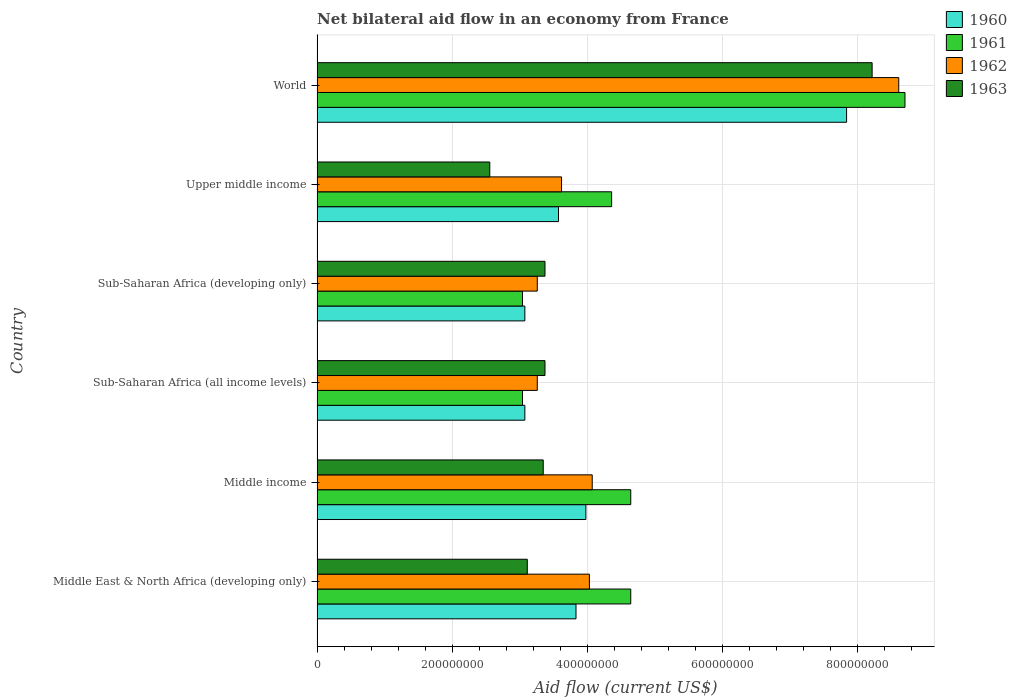How many different coloured bars are there?
Give a very brief answer. 4. How many groups of bars are there?
Keep it short and to the point. 6. How many bars are there on the 5th tick from the bottom?
Ensure brevity in your answer.  4. What is the label of the 3rd group of bars from the top?
Offer a terse response. Sub-Saharan Africa (developing only). In how many cases, is the number of bars for a given country not equal to the number of legend labels?
Your answer should be very brief. 0. What is the net bilateral aid flow in 1961 in World?
Provide a short and direct response. 8.70e+08. Across all countries, what is the maximum net bilateral aid flow in 1961?
Provide a succinct answer. 8.70e+08. Across all countries, what is the minimum net bilateral aid flow in 1962?
Give a very brief answer. 3.26e+08. In which country was the net bilateral aid flow in 1961 maximum?
Keep it short and to the point. World. In which country was the net bilateral aid flow in 1961 minimum?
Offer a very short reply. Sub-Saharan Africa (all income levels). What is the total net bilateral aid flow in 1961 in the graph?
Your answer should be very brief. 2.84e+09. What is the difference between the net bilateral aid flow in 1960 in Sub-Saharan Africa (all income levels) and that in Upper middle income?
Provide a short and direct response. -4.98e+07. What is the difference between the net bilateral aid flow in 1960 in Sub-Saharan Africa (developing only) and the net bilateral aid flow in 1961 in Upper middle income?
Your answer should be very brief. -1.28e+08. What is the average net bilateral aid flow in 1960 per country?
Offer a very short reply. 4.23e+08. What is the difference between the net bilateral aid flow in 1961 and net bilateral aid flow in 1963 in Sub-Saharan Africa (developing only)?
Give a very brief answer. -3.33e+07. In how many countries, is the net bilateral aid flow in 1961 greater than 200000000 US$?
Your response must be concise. 6. What is the ratio of the net bilateral aid flow in 1960 in Middle income to that in Sub-Saharan Africa (developing only)?
Offer a terse response. 1.29. What is the difference between the highest and the second highest net bilateral aid flow in 1961?
Make the answer very short. 4.06e+08. What is the difference between the highest and the lowest net bilateral aid flow in 1962?
Your answer should be very brief. 5.35e+08. In how many countries, is the net bilateral aid flow in 1962 greater than the average net bilateral aid flow in 1962 taken over all countries?
Keep it short and to the point. 1. Is the sum of the net bilateral aid flow in 1961 in Sub-Saharan Africa (all income levels) and World greater than the maximum net bilateral aid flow in 1963 across all countries?
Offer a terse response. Yes. Is it the case that in every country, the sum of the net bilateral aid flow in 1961 and net bilateral aid flow in 1960 is greater than the sum of net bilateral aid flow in 1963 and net bilateral aid flow in 1962?
Give a very brief answer. No. What does the 4th bar from the bottom in Middle East & North Africa (developing only) represents?
Keep it short and to the point. 1963. How many bars are there?
Your answer should be very brief. 24. Are all the bars in the graph horizontal?
Offer a terse response. Yes. How many countries are there in the graph?
Keep it short and to the point. 6. How many legend labels are there?
Ensure brevity in your answer.  4. What is the title of the graph?
Provide a succinct answer. Net bilateral aid flow in an economy from France. What is the label or title of the X-axis?
Your response must be concise. Aid flow (current US$). What is the label or title of the Y-axis?
Give a very brief answer. Country. What is the Aid flow (current US$) in 1960 in Middle East & North Africa (developing only)?
Offer a very short reply. 3.83e+08. What is the Aid flow (current US$) of 1961 in Middle East & North Africa (developing only)?
Ensure brevity in your answer.  4.64e+08. What is the Aid flow (current US$) in 1962 in Middle East & North Africa (developing only)?
Offer a very short reply. 4.03e+08. What is the Aid flow (current US$) of 1963 in Middle East & North Africa (developing only)?
Your response must be concise. 3.11e+08. What is the Aid flow (current US$) in 1960 in Middle income?
Provide a succinct answer. 3.98e+08. What is the Aid flow (current US$) in 1961 in Middle income?
Provide a succinct answer. 4.64e+08. What is the Aid flow (current US$) in 1962 in Middle income?
Your response must be concise. 4.07e+08. What is the Aid flow (current US$) of 1963 in Middle income?
Offer a very short reply. 3.35e+08. What is the Aid flow (current US$) of 1960 in Sub-Saharan Africa (all income levels)?
Give a very brief answer. 3.08e+08. What is the Aid flow (current US$) of 1961 in Sub-Saharan Africa (all income levels)?
Your answer should be compact. 3.04e+08. What is the Aid flow (current US$) of 1962 in Sub-Saharan Africa (all income levels)?
Keep it short and to the point. 3.26e+08. What is the Aid flow (current US$) of 1963 in Sub-Saharan Africa (all income levels)?
Ensure brevity in your answer.  3.37e+08. What is the Aid flow (current US$) of 1960 in Sub-Saharan Africa (developing only)?
Ensure brevity in your answer.  3.08e+08. What is the Aid flow (current US$) in 1961 in Sub-Saharan Africa (developing only)?
Your response must be concise. 3.04e+08. What is the Aid flow (current US$) in 1962 in Sub-Saharan Africa (developing only)?
Your response must be concise. 3.26e+08. What is the Aid flow (current US$) in 1963 in Sub-Saharan Africa (developing only)?
Your response must be concise. 3.37e+08. What is the Aid flow (current US$) of 1960 in Upper middle income?
Your answer should be compact. 3.57e+08. What is the Aid flow (current US$) in 1961 in Upper middle income?
Your answer should be compact. 4.36e+08. What is the Aid flow (current US$) in 1962 in Upper middle income?
Make the answer very short. 3.62e+08. What is the Aid flow (current US$) in 1963 in Upper middle income?
Provide a succinct answer. 2.56e+08. What is the Aid flow (current US$) of 1960 in World?
Your answer should be very brief. 7.84e+08. What is the Aid flow (current US$) in 1961 in World?
Your answer should be compact. 8.70e+08. What is the Aid flow (current US$) of 1962 in World?
Your response must be concise. 8.61e+08. What is the Aid flow (current US$) in 1963 in World?
Make the answer very short. 8.21e+08. Across all countries, what is the maximum Aid flow (current US$) in 1960?
Provide a short and direct response. 7.84e+08. Across all countries, what is the maximum Aid flow (current US$) in 1961?
Offer a very short reply. 8.70e+08. Across all countries, what is the maximum Aid flow (current US$) in 1962?
Your response must be concise. 8.61e+08. Across all countries, what is the maximum Aid flow (current US$) of 1963?
Give a very brief answer. 8.21e+08. Across all countries, what is the minimum Aid flow (current US$) in 1960?
Your response must be concise. 3.08e+08. Across all countries, what is the minimum Aid flow (current US$) in 1961?
Offer a terse response. 3.04e+08. Across all countries, what is the minimum Aid flow (current US$) of 1962?
Provide a succinct answer. 3.26e+08. Across all countries, what is the minimum Aid flow (current US$) in 1963?
Make the answer very short. 2.56e+08. What is the total Aid flow (current US$) in 1960 in the graph?
Provide a short and direct response. 2.54e+09. What is the total Aid flow (current US$) in 1961 in the graph?
Provide a short and direct response. 2.84e+09. What is the total Aid flow (current US$) of 1962 in the graph?
Make the answer very short. 2.68e+09. What is the total Aid flow (current US$) of 1963 in the graph?
Offer a terse response. 2.40e+09. What is the difference between the Aid flow (current US$) of 1960 in Middle East & North Africa (developing only) and that in Middle income?
Your response must be concise. -1.46e+07. What is the difference between the Aid flow (current US$) of 1961 in Middle East & North Africa (developing only) and that in Middle income?
Ensure brevity in your answer.  0. What is the difference between the Aid flow (current US$) of 1962 in Middle East & North Africa (developing only) and that in Middle income?
Make the answer very short. -4.20e+06. What is the difference between the Aid flow (current US$) of 1963 in Middle East & North Africa (developing only) and that in Middle income?
Make the answer very short. -2.36e+07. What is the difference between the Aid flow (current US$) in 1960 in Middle East & North Africa (developing only) and that in Sub-Saharan Africa (all income levels)?
Make the answer very short. 7.57e+07. What is the difference between the Aid flow (current US$) of 1961 in Middle East & North Africa (developing only) and that in Sub-Saharan Africa (all income levels)?
Give a very brief answer. 1.60e+08. What is the difference between the Aid flow (current US$) of 1962 in Middle East & North Africa (developing only) and that in Sub-Saharan Africa (all income levels)?
Give a very brief answer. 7.71e+07. What is the difference between the Aid flow (current US$) in 1963 in Middle East & North Africa (developing only) and that in Sub-Saharan Africa (all income levels)?
Give a very brief answer. -2.62e+07. What is the difference between the Aid flow (current US$) of 1960 in Middle East & North Africa (developing only) and that in Sub-Saharan Africa (developing only)?
Make the answer very short. 7.57e+07. What is the difference between the Aid flow (current US$) in 1961 in Middle East & North Africa (developing only) and that in Sub-Saharan Africa (developing only)?
Make the answer very short. 1.60e+08. What is the difference between the Aid flow (current US$) of 1962 in Middle East & North Africa (developing only) and that in Sub-Saharan Africa (developing only)?
Offer a terse response. 7.71e+07. What is the difference between the Aid flow (current US$) in 1963 in Middle East & North Africa (developing only) and that in Sub-Saharan Africa (developing only)?
Give a very brief answer. -2.62e+07. What is the difference between the Aid flow (current US$) in 1960 in Middle East & North Africa (developing only) and that in Upper middle income?
Provide a short and direct response. 2.59e+07. What is the difference between the Aid flow (current US$) in 1961 in Middle East & North Africa (developing only) and that in Upper middle income?
Your answer should be very brief. 2.83e+07. What is the difference between the Aid flow (current US$) of 1962 in Middle East & North Africa (developing only) and that in Upper middle income?
Keep it short and to the point. 4.12e+07. What is the difference between the Aid flow (current US$) of 1963 in Middle East & North Africa (developing only) and that in Upper middle income?
Offer a terse response. 5.55e+07. What is the difference between the Aid flow (current US$) in 1960 in Middle East & North Africa (developing only) and that in World?
Offer a very short reply. -4.00e+08. What is the difference between the Aid flow (current US$) in 1961 in Middle East & North Africa (developing only) and that in World?
Offer a very short reply. -4.06e+08. What is the difference between the Aid flow (current US$) in 1962 in Middle East & North Africa (developing only) and that in World?
Provide a short and direct response. -4.58e+08. What is the difference between the Aid flow (current US$) in 1963 in Middle East & North Africa (developing only) and that in World?
Ensure brevity in your answer.  -5.10e+08. What is the difference between the Aid flow (current US$) of 1960 in Middle income and that in Sub-Saharan Africa (all income levels)?
Your answer should be compact. 9.03e+07. What is the difference between the Aid flow (current US$) in 1961 in Middle income and that in Sub-Saharan Africa (all income levels)?
Ensure brevity in your answer.  1.60e+08. What is the difference between the Aid flow (current US$) of 1962 in Middle income and that in Sub-Saharan Africa (all income levels)?
Keep it short and to the point. 8.13e+07. What is the difference between the Aid flow (current US$) of 1963 in Middle income and that in Sub-Saharan Africa (all income levels)?
Provide a succinct answer. -2.60e+06. What is the difference between the Aid flow (current US$) in 1960 in Middle income and that in Sub-Saharan Africa (developing only)?
Offer a terse response. 9.03e+07. What is the difference between the Aid flow (current US$) in 1961 in Middle income and that in Sub-Saharan Africa (developing only)?
Make the answer very short. 1.60e+08. What is the difference between the Aid flow (current US$) in 1962 in Middle income and that in Sub-Saharan Africa (developing only)?
Your answer should be very brief. 8.13e+07. What is the difference between the Aid flow (current US$) in 1963 in Middle income and that in Sub-Saharan Africa (developing only)?
Ensure brevity in your answer.  -2.60e+06. What is the difference between the Aid flow (current US$) of 1960 in Middle income and that in Upper middle income?
Give a very brief answer. 4.05e+07. What is the difference between the Aid flow (current US$) of 1961 in Middle income and that in Upper middle income?
Your response must be concise. 2.83e+07. What is the difference between the Aid flow (current US$) of 1962 in Middle income and that in Upper middle income?
Offer a terse response. 4.54e+07. What is the difference between the Aid flow (current US$) in 1963 in Middle income and that in Upper middle income?
Your response must be concise. 7.91e+07. What is the difference between the Aid flow (current US$) in 1960 in Middle income and that in World?
Make the answer very short. -3.86e+08. What is the difference between the Aid flow (current US$) in 1961 in Middle income and that in World?
Ensure brevity in your answer.  -4.06e+08. What is the difference between the Aid flow (current US$) in 1962 in Middle income and that in World?
Offer a terse response. -4.54e+08. What is the difference between the Aid flow (current US$) in 1963 in Middle income and that in World?
Provide a short and direct response. -4.87e+08. What is the difference between the Aid flow (current US$) of 1960 in Sub-Saharan Africa (all income levels) and that in Sub-Saharan Africa (developing only)?
Provide a succinct answer. 0. What is the difference between the Aid flow (current US$) of 1961 in Sub-Saharan Africa (all income levels) and that in Sub-Saharan Africa (developing only)?
Provide a short and direct response. 0. What is the difference between the Aid flow (current US$) in 1963 in Sub-Saharan Africa (all income levels) and that in Sub-Saharan Africa (developing only)?
Ensure brevity in your answer.  0. What is the difference between the Aid flow (current US$) in 1960 in Sub-Saharan Africa (all income levels) and that in Upper middle income?
Give a very brief answer. -4.98e+07. What is the difference between the Aid flow (current US$) of 1961 in Sub-Saharan Africa (all income levels) and that in Upper middle income?
Your answer should be compact. -1.32e+08. What is the difference between the Aid flow (current US$) of 1962 in Sub-Saharan Africa (all income levels) and that in Upper middle income?
Your answer should be compact. -3.59e+07. What is the difference between the Aid flow (current US$) in 1963 in Sub-Saharan Africa (all income levels) and that in Upper middle income?
Offer a very short reply. 8.17e+07. What is the difference between the Aid flow (current US$) in 1960 in Sub-Saharan Africa (all income levels) and that in World?
Ensure brevity in your answer.  -4.76e+08. What is the difference between the Aid flow (current US$) in 1961 in Sub-Saharan Africa (all income levels) and that in World?
Make the answer very short. -5.66e+08. What is the difference between the Aid flow (current US$) in 1962 in Sub-Saharan Africa (all income levels) and that in World?
Provide a succinct answer. -5.35e+08. What is the difference between the Aid flow (current US$) in 1963 in Sub-Saharan Africa (all income levels) and that in World?
Give a very brief answer. -4.84e+08. What is the difference between the Aid flow (current US$) in 1960 in Sub-Saharan Africa (developing only) and that in Upper middle income?
Your answer should be compact. -4.98e+07. What is the difference between the Aid flow (current US$) in 1961 in Sub-Saharan Africa (developing only) and that in Upper middle income?
Make the answer very short. -1.32e+08. What is the difference between the Aid flow (current US$) in 1962 in Sub-Saharan Africa (developing only) and that in Upper middle income?
Give a very brief answer. -3.59e+07. What is the difference between the Aid flow (current US$) of 1963 in Sub-Saharan Africa (developing only) and that in Upper middle income?
Offer a very short reply. 8.17e+07. What is the difference between the Aid flow (current US$) of 1960 in Sub-Saharan Africa (developing only) and that in World?
Offer a very short reply. -4.76e+08. What is the difference between the Aid flow (current US$) of 1961 in Sub-Saharan Africa (developing only) and that in World?
Give a very brief answer. -5.66e+08. What is the difference between the Aid flow (current US$) of 1962 in Sub-Saharan Africa (developing only) and that in World?
Make the answer very short. -5.35e+08. What is the difference between the Aid flow (current US$) in 1963 in Sub-Saharan Africa (developing only) and that in World?
Your response must be concise. -4.84e+08. What is the difference between the Aid flow (current US$) of 1960 in Upper middle income and that in World?
Provide a succinct answer. -4.26e+08. What is the difference between the Aid flow (current US$) in 1961 in Upper middle income and that in World?
Your answer should be compact. -4.34e+08. What is the difference between the Aid flow (current US$) in 1962 in Upper middle income and that in World?
Offer a very short reply. -4.99e+08. What is the difference between the Aid flow (current US$) in 1963 in Upper middle income and that in World?
Make the answer very short. -5.66e+08. What is the difference between the Aid flow (current US$) of 1960 in Middle East & North Africa (developing only) and the Aid flow (current US$) of 1961 in Middle income?
Provide a succinct answer. -8.10e+07. What is the difference between the Aid flow (current US$) of 1960 in Middle East & North Africa (developing only) and the Aid flow (current US$) of 1962 in Middle income?
Keep it short and to the point. -2.40e+07. What is the difference between the Aid flow (current US$) of 1960 in Middle East & North Africa (developing only) and the Aid flow (current US$) of 1963 in Middle income?
Keep it short and to the point. 4.85e+07. What is the difference between the Aid flow (current US$) in 1961 in Middle East & North Africa (developing only) and the Aid flow (current US$) in 1962 in Middle income?
Keep it short and to the point. 5.70e+07. What is the difference between the Aid flow (current US$) of 1961 in Middle East & North Africa (developing only) and the Aid flow (current US$) of 1963 in Middle income?
Your answer should be very brief. 1.30e+08. What is the difference between the Aid flow (current US$) of 1962 in Middle East & North Africa (developing only) and the Aid flow (current US$) of 1963 in Middle income?
Give a very brief answer. 6.83e+07. What is the difference between the Aid flow (current US$) of 1960 in Middle East & North Africa (developing only) and the Aid flow (current US$) of 1961 in Sub-Saharan Africa (all income levels)?
Give a very brief answer. 7.92e+07. What is the difference between the Aid flow (current US$) in 1960 in Middle East & North Africa (developing only) and the Aid flow (current US$) in 1962 in Sub-Saharan Africa (all income levels)?
Your response must be concise. 5.73e+07. What is the difference between the Aid flow (current US$) in 1960 in Middle East & North Africa (developing only) and the Aid flow (current US$) in 1963 in Sub-Saharan Africa (all income levels)?
Your answer should be very brief. 4.59e+07. What is the difference between the Aid flow (current US$) of 1961 in Middle East & North Africa (developing only) and the Aid flow (current US$) of 1962 in Sub-Saharan Africa (all income levels)?
Offer a very short reply. 1.38e+08. What is the difference between the Aid flow (current US$) of 1961 in Middle East & North Africa (developing only) and the Aid flow (current US$) of 1963 in Sub-Saharan Africa (all income levels)?
Provide a short and direct response. 1.27e+08. What is the difference between the Aid flow (current US$) of 1962 in Middle East & North Africa (developing only) and the Aid flow (current US$) of 1963 in Sub-Saharan Africa (all income levels)?
Provide a short and direct response. 6.57e+07. What is the difference between the Aid flow (current US$) of 1960 in Middle East & North Africa (developing only) and the Aid flow (current US$) of 1961 in Sub-Saharan Africa (developing only)?
Your response must be concise. 7.92e+07. What is the difference between the Aid flow (current US$) in 1960 in Middle East & North Africa (developing only) and the Aid flow (current US$) in 1962 in Sub-Saharan Africa (developing only)?
Keep it short and to the point. 5.73e+07. What is the difference between the Aid flow (current US$) in 1960 in Middle East & North Africa (developing only) and the Aid flow (current US$) in 1963 in Sub-Saharan Africa (developing only)?
Your answer should be compact. 4.59e+07. What is the difference between the Aid flow (current US$) in 1961 in Middle East & North Africa (developing only) and the Aid flow (current US$) in 1962 in Sub-Saharan Africa (developing only)?
Your response must be concise. 1.38e+08. What is the difference between the Aid flow (current US$) of 1961 in Middle East & North Africa (developing only) and the Aid flow (current US$) of 1963 in Sub-Saharan Africa (developing only)?
Provide a succinct answer. 1.27e+08. What is the difference between the Aid flow (current US$) in 1962 in Middle East & North Africa (developing only) and the Aid flow (current US$) in 1963 in Sub-Saharan Africa (developing only)?
Provide a succinct answer. 6.57e+07. What is the difference between the Aid flow (current US$) in 1960 in Middle East & North Africa (developing only) and the Aid flow (current US$) in 1961 in Upper middle income?
Keep it short and to the point. -5.27e+07. What is the difference between the Aid flow (current US$) in 1960 in Middle East & North Africa (developing only) and the Aid flow (current US$) in 1962 in Upper middle income?
Offer a terse response. 2.14e+07. What is the difference between the Aid flow (current US$) in 1960 in Middle East & North Africa (developing only) and the Aid flow (current US$) in 1963 in Upper middle income?
Offer a terse response. 1.28e+08. What is the difference between the Aid flow (current US$) in 1961 in Middle East & North Africa (developing only) and the Aid flow (current US$) in 1962 in Upper middle income?
Provide a succinct answer. 1.02e+08. What is the difference between the Aid flow (current US$) in 1961 in Middle East & North Africa (developing only) and the Aid flow (current US$) in 1963 in Upper middle income?
Offer a terse response. 2.09e+08. What is the difference between the Aid flow (current US$) in 1962 in Middle East & North Africa (developing only) and the Aid flow (current US$) in 1963 in Upper middle income?
Offer a very short reply. 1.47e+08. What is the difference between the Aid flow (current US$) in 1960 in Middle East & North Africa (developing only) and the Aid flow (current US$) in 1961 in World?
Make the answer very short. -4.87e+08. What is the difference between the Aid flow (current US$) in 1960 in Middle East & North Africa (developing only) and the Aid flow (current US$) in 1962 in World?
Offer a terse response. -4.78e+08. What is the difference between the Aid flow (current US$) in 1960 in Middle East & North Africa (developing only) and the Aid flow (current US$) in 1963 in World?
Offer a terse response. -4.38e+08. What is the difference between the Aid flow (current US$) in 1961 in Middle East & North Africa (developing only) and the Aid flow (current US$) in 1962 in World?
Provide a short and direct response. -3.97e+08. What is the difference between the Aid flow (current US$) of 1961 in Middle East & North Africa (developing only) and the Aid flow (current US$) of 1963 in World?
Offer a terse response. -3.57e+08. What is the difference between the Aid flow (current US$) of 1962 in Middle East & North Africa (developing only) and the Aid flow (current US$) of 1963 in World?
Give a very brief answer. -4.18e+08. What is the difference between the Aid flow (current US$) in 1960 in Middle income and the Aid flow (current US$) in 1961 in Sub-Saharan Africa (all income levels)?
Give a very brief answer. 9.38e+07. What is the difference between the Aid flow (current US$) in 1960 in Middle income and the Aid flow (current US$) in 1962 in Sub-Saharan Africa (all income levels)?
Offer a very short reply. 7.19e+07. What is the difference between the Aid flow (current US$) in 1960 in Middle income and the Aid flow (current US$) in 1963 in Sub-Saharan Africa (all income levels)?
Make the answer very short. 6.05e+07. What is the difference between the Aid flow (current US$) of 1961 in Middle income and the Aid flow (current US$) of 1962 in Sub-Saharan Africa (all income levels)?
Your answer should be very brief. 1.38e+08. What is the difference between the Aid flow (current US$) of 1961 in Middle income and the Aid flow (current US$) of 1963 in Sub-Saharan Africa (all income levels)?
Offer a terse response. 1.27e+08. What is the difference between the Aid flow (current US$) in 1962 in Middle income and the Aid flow (current US$) in 1963 in Sub-Saharan Africa (all income levels)?
Offer a terse response. 6.99e+07. What is the difference between the Aid flow (current US$) of 1960 in Middle income and the Aid flow (current US$) of 1961 in Sub-Saharan Africa (developing only)?
Provide a succinct answer. 9.38e+07. What is the difference between the Aid flow (current US$) of 1960 in Middle income and the Aid flow (current US$) of 1962 in Sub-Saharan Africa (developing only)?
Ensure brevity in your answer.  7.19e+07. What is the difference between the Aid flow (current US$) in 1960 in Middle income and the Aid flow (current US$) in 1963 in Sub-Saharan Africa (developing only)?
Your answer should be very brief. 6.05e+07. What is the difference between the Aid flow (current US$) in 1961 in Middle income and the Aid flow (current US$) in 1962 in Sub-Saharan Africa (developing only)?
Provide a short and direct response. 1.38e+08. What is the difference between the Aid flow (current US$) of 1961 in Middle income and the Aid flow (current US$) of 1963 in Sub-Saharan Africa (developing only)?
Offer a very short reply. 1.27e+08. What is the difference between the Aid flow (current US$) of 1962 in Middle income and the Aid flow (current US$) of 1963 in Sub-Saharan Africa (developing only)?
Your response must be concise. 6.99e+07. What is the difference between the Aid flow (current US$) in 1960 in Middle income and the Aid flow (current US$) in 1961 in Upper middle income?
Your answer should be very brief. -3.81e+07. What is the difference between the Aid flow (current US$) of 1960 in Middle income and the Aid flow (current US$) of 1962 in Upper middle income?
Provide a short and direct response. 3.60e+07. What is the difference between the Aid flow (current US$) of 1960 in Middle income and the Aid flow (current US$) of 1963 in Upper middle income?
Keep it short and to the point. 1.42e+08. What is the difference between the Aid flow (current US$) of 1961 in Middle income and the Aid flow (current US$) of 1962 in Upper middle income?
Keep it short and to the point. 1.02e+08. What is the difference between the Aid flow (current US$) of 1961 in Middle income and the Aid flow (current US$) of 1963 in Upper middle income?
Your response must be concise. 2.09e+08. What is the difference between the Aid flow (current US$) of 1962 in Middle income and the Aid flow (current US$) of 1963 in Upper middle income?
Your response must be concise. 1.52e+08. What is the difference between the Aid flow (current US$) of 1960 in Middle income and the Aid flow (current US$) of 1961 in World?
Your answer should be compact. -4.72e+08. What is the difference between the Aid flow (current US$) of 1960 in Middle income and the Aid flow (current US$) of 1962 in World?
Your response must be concise. -4.63e+08. What is the difference between the Aid flow (current US$) of 1960 in Middle income and the Aid flow (current US$) of 1963 in World?
Provide a short and direct response. -4.24e+08. What is the difference between the Aid flow (current US$) of 1961 in Middle income and the Aid flow (current US$) of 1962 in World?
Provide a succinct answer. -3.97e+08. What is the difference between the Aid flow (current US$) in 1961 in Middle income and the Aid flow (current US$) in 1963 in World?
Offer a terse response. -3.57e+08. What is the difference between the Aid flow (current US$) in 1962 in Middle income and the Aid flow (current US$) in 1963 in World?
Make the answer very short. -4.14e+08. What is the difference between the Aid flow (current US$) in 1960 in Sub-Saharan Africa (all income levels) and the Aid flow (current US$) in 1961 in Sub-Saharan Africa (developing only)?
Provide a short and direct response. 3.50e+06. What is the difference between the Aid flow (current US$) in 1960 in Sub-Saharan Africa (all income levels) and the Aid flow (current US$) in 1962 in Sub-Saharan Africa (developing only)?
Your response must be concise. -1.84e+07. What is the difference between the Aid flow (current US$) of 1960 in Sub-Saharan Africa (all income levels) and the Aid flow (current US$) of 1963 in Sub-Saharan Africa (developing only)?
Offer a terse response. -2.98e+07. What is the difference between the Aid flow (current US$) of 1961 in Sub-Saharan Africa (all income levels) and the Aid flow (current US$) of 1962 in Sub-Saharan Africa (developing only)?
Your answer should be very brief. -2.19e+07. What is the difference between the Aid flow (current US$) of 1961 in Sub-Saharan Africa (all income levels) and the Aid flow (current US$) of 1963 in Sub-Saharan Africa (developing only)?
Offer a very short reply. -3.33e+07. What is the difference between the Aid flow (current US$) in 1962 in Sub-Saharan Africa (all income levels) and the Aid flow (current US$) in 1963 in Sub-Saharan Africa (developing only)?
Provide a short and direct response. -1.14e+07. What is the difference between the Aid flow (current US$) of 1960 in Sub-Saharan Africa (all income levels) and the Aid flow (current US$) of 1961 in Upper middle income?
Offer a very short reply. -1.28e+08. What is the difference between the Aid flow (current US$) in 1960 in Sub-Saharan Africa (all income levels) and the Aid flow (current US$) in 1962 in Upper middle income?
Provide a short and direct response. -5.43e+07. What is the difference between the Aid flow (current US$) of 1960 in Sub-Saharan Africa (all income levels) and the Aid flow (current US$) of 1963 in Upper middle income?
Your response must be concise. 5.19e+07. What is the difference between the Aid flow (current US$) in 1961 in Sub-Saharan Africa (all income levels) and the Aid flow (current US$) in 1962 in Upper middle income?
Offer a terse response. -5.78e+07. What is the difference between the Aid flow (current US$) of 1961 in Sub-Saharan Africa (all income levels) and the Aid flow (current US$) of 1963 in Upper middle income?
Make the answer very short. 4.84e+07. What is the difference between the Aid flow (current US$) in 1962 in Sub-Saharan Africa (all income levels) and the Aid flow (current US$) in 1963 in Upper middle income?
Keep it short and to the point. 7.03e+07. What is the difference between the Aid flow (current US$) of 1960 in Sub-Saharan Africa (all income levels) and the Aid flow (current US$) of 1961 in World?
Ensure brevity in your answer.  -5.62e+08. What is the difference between the Aid flow (current US$) of 1960 in Sub-Saharan Africa (all income levels) and the Aid flow (current US$) of 1962 in World?
Ensure brevity in your answer.  -5.53e+08. What is the difference between the Aid flow (current US$) of 1960 in Sub-Saharan Africa (all income levels) and the Aid flow (current US$) of 1963 in World?
Provide a short and direct response. -5.14e+08. What is the difference between the Aid flow (current US$) in 1961 in Sub-Saharan Africa (all income levels) and the Aid flow (current US$) in 1962 in World?
Your answer should be very brief. -5.57e+08. What is the difference between the Aid flow (current US$) in 1961 in Sub-Saharan Africa (all income levels) and the Aid flow (current US$) in 1963 in World?
Provide a short and direct response. -5.17e+08. What is the difference between the Aid flow (current US$) of 1962 in Sub-Saharan Africa (all income levels) and the Aid flow (current US$) of 1963 in World?
Ensure brevity in your answer.  -4.96e+08. What is the difference between the Aid flow (current US$) in 1960 in Sub-Saharan Africa (developing only) and the Aid flow (current US$) in 1961 in Upper middle income?
Ensure brevity in your answer.  -1.28e+08. What is the difference between the Aid flow (current US$) in 1960 in Sub-Saharan Africa (developing only) and the Aid flow (current US$) in 1962 in Upper middle income?
Your answer should be very brief. -5.43e+07. What is the difference between the Aid flow (current US$) of 1960 in Sub-Saharan Africa (developing only) and the Aid flow (current US$) of 1963 in Upper middle income?
Your answer should be very brief. 5.19e+07. What is the difference between the Aid flow (current US$) in 1961 in Sub-Saharan Africa (developing only) and the Aid flow (current US$) in 1962 in Upper middle income?
Give a very brief answer. -5.78e+07. What is the difference between the Aid flow (current US$) of 1961 in Sub-Saharan Africa (developing only) and the Aid flow (current US$) of 1963 in Upper middle income?
Keep it short and to the point. 4.84e+07. What is the difference between the Aid flow (current US$) in 1962 in Sub-Saharan Africa (developing only) and the Aid flow (current US$) in 1963 in Upper middle income?
Give a very brief answer. 7.03e+07. What is the difference between the Aid flow (current US$) of 1960 in Sub-Saharan Africa (developing only) and the Aid flow (current US$) of 1961 in World?
Make the answer very short. -5.62e+08. What is the difference between the Aid flow (current US$) of 1960 in Sub-Saharan Africa (developing only) and the Aid flow (current US$) of 1962 in World?
Offer a very short reply. -5.53e+08. What is the difference between the Aid flow (current US$) of 1960 in Sub-Saharan Africa (developing only) and the Aid flow (current US$) of 1963 in World?
Ensure brevity in your answer.  -5.14e+08. What is the difference between the Aid flow (current US$) of 1961 in Sub-Saharan Africa (developing only) and the Aid flow (current US$) of 1962 in World?
Your answer should be compact. -5.57e+08. What is the difference between the Aid flow (current US$) in 1961 in Sub-Saharan Africa (developing only) and the Aid flow (current US$) in 1963 in World?
Your answer should be compact. -5.17e+08. What is the difference between the Aid flow (current US$) in 1962 in Sub-Saharan Africa (developing only) and the Aid flow (current US$) in 1963 in World?
Keep it short and to the point. -4.96e+08. What is the difference between the Aid flow (current US$) of 1960 in Upper middle income and the Aid flow (current US$) of 1961 in World?
Offer a very short reply. -5.13e+08. What is the difference between the Aid flow (current US$) of 1960 in Upper middle income and the Aid flow (current US$) of 1962 in World?
Your answer should be very brief. -5.04e+08. What is the difference between the Aid flow (current US$) in 1960 in Upper middle income and the Aid flow (current US$) in 1963 in World?
Offer a terse response. -4.64e+08. What is the difference between the Aid flow (current US$) of 1961 in Upper middle income and the Aid flow (current US$) of 1962 in World?
Offer a terse response. -4.25e+08. What is the difference between the Aid flow (current US$) in 1961 in Upper middle income and the Aid flow (current US$) in 1963 in World?
Give a very brief answer. -3.86e+08. What is the difference between the Aid flow (current US$) of 1962 in Upper middle income and the Aid flow (current US$) of 1963 in World?
Give a very brief answer. -4.60e+08. What is the average Aid flow (current US$) of 1960 per country?
Provide a short and direct response. 4.23e+08. What is the average Aid flow (current US$) of 1961 per country?
Keep it short and to the point. 4.74e+08. What is the average Aid flow (current US$) of 1962 per country?
Give a very brief answer. 4.47e+08. What is the average Aid flow (current US$) of 1963 per country?
Your answer should be compact. 4.00e+08. What is the difference between the Aid flow (current US$) of 1960 and Aid flow (current US$) of 1961 in Middle East & North Africa (developing only)?
Your answer should be compact. -8.10e+07. What is the difference between the Aid flow (current US$) of 1960 and Aid flow (current US$) of 1962 in Middle East & North Africa (developing only)?
Your answer should be compact. -1.98e+07. What is the difference between the Aid flow (current US$) in 1960 and Aid flow (current US$) in 1963 in Middle East & North Africa (developing only)?
Ensure brevity in your answer.  7.21e+07. What is the difference between the Aid flow (current US$) in 1961 and Aid flow (current US$) in 1962 in Middle East & North Africa (developing only)?
Your answer should be very brief. 6.12e+07. What is the difference between the Aid flow (current US$) of 1961 and Aid flow (current US$) of 1963 in Middle East & North Africa (developing only)?
Your response must be concise. 1.53e+08. What is the difference between the Aid flow (current US$) of 1962 and Aid flow (current US$) of 1963 in Middle East & North Africa (developing only)?
Your answer should be very brief. 9.19e+07. What is the difference between the Aid flow (current US$) of 1960 and Aid flow (current US$) of 1961 in Middle income?
Your answer should be very brief. -6.64e+07. What is the difference between the Aid flow (current US$) in 1960 and Aid flow (current US$) in 1962 in Middle income?
Your answer should be very brief. -9.40e+06. What is the difference between the Aid flow (current US$) in 1960 and Aid flow (current US$) in 1963 in Middle income?
Your answer should be compact. 6.31e+07. What is the difference between the Aid flow (current US$) of 1961 and Aid flow (current US$) of 1962 in Middle income?
Offer a very short reply. 5.70e+07. What is the difference between the Aid flow (current US$) in 1961 and Aid flow (current US$) in 1963 in Middle income?
Offer a very short reply. 1.30e+08. What is the difference between the Aid flow (current US$) of 1962 and Aid flow (current US$) of 1963 in Middle income?
Keep it short and to the point. 7.25e+07. What is the difference between the Aid flow (current US$) in 1960 and Aid flow (current US$) in 1961 in Sub-Saharan Africa (all income levels)?
Provide a succinct answer. 3.50e+06. What is the difference between the Aid flow (current US$) of 1960 and Aid flow (current US$) of 1962 in Sub-Saharan Africa (all income levels)?
Your response must be concise. -1.84e+07. What is the difference between the Aid flow (current US$) of 1960 and Aid flow (current US$) of 1963 in Sub-Saharan Africa (all income levels)?
Offer a very short reply. -2.98e+07. What is the difference between the Aid flow (current US$) in 1961 and Aid flow (current US$) in 1962 in Sub-Saharan Africa (all income levels)?
Your answer should be compact. -2.19e+07. What is the difference between the Aid flow (current US$) in 1961 and Aid flow (current US$) in 1963 in Sub-Saharan Africa (all income levels)?
Make the answer very short. -3.33e+07. What is the difference between the Aid flow (current US$) of 1962 and Aid flow (current US$) of 1963 in Sub-Saharan Africa (all income levels)?
Provide a short and direct response. -1.14e+07. What is the difference between the Aid flow (current US$) in 1960 and Aid flow (current US$) in 1961 in Sub-Saharan Africa (developing only)?
Offer a terse response. 3.50e+06. What is the difference between the Aid flow (current US$) in 1960 and Aid flow (current US$) in 1962 in Sub-Saharan Africa (developing only)?
Ensure brevity in your answer.  -1.84e+07. What is the difference between the Aid flow (current US$) in 1960 and Aid flow (current US$) in 1963 in Sub-Saharan Africa (developing only)?
Give a very brief answer. -2.98e+07. What is the difference between the Aid flow (current US$) in 1961 and Aid flow (current US$) in 1962 in Sub-Saharan Africa (developing only)?
Offer a very short reply. -2.19e+07. What is the difference between the Aid flow (current US$) in 1961 and Aid flow (current US$) in 1963 in Sub-Saharan Africa (developing only)?
Your answer should be compact. -3.33e+07. What is the difference between the Aid flow (current US$) in 1962 and Aid flow (current US$) in 1963 in Sub-Saharan Africa (developing only)?
Provide a succinct answer. -1.14e+07. What is the difference between the Aid flow (current US$) of 1960 and Aid flow (current US$) of 1961 in Upper middle income?
Provide a succinct answer. -7.86e+07. What is the difference between the Aid flow (current US$) of 1960 and Aid flow (current US$) of 1962 in Upper middle income?
Provide a succinct answer. -4.50e+06. What is the difference between the Aid flow (current US$) in 1960 and Aid flow (current US$) in 1963 in Upper middle income?
Give a very brief answer. 1.02e+08. What is the difference between the Aid flow (current US$) in 1961 and Aid flow (current US$) in 1962 in Upper middle income?
Offer a terse response. 7.41e+07. What is the difference between the Aid flow (current US$) in 1961 and Aid flow (current US$) in 1963 in Upper middle income?
Your answer should be compact. 1.80e+08. What is the difference between the Aid flow (current US$) in 1962 and Aid flow (current US$) in 1963 in Upper middle income?
Make the answer very short. 1.06e+08. What is the difference between the Aid flow (current US$) in 1960 and Aid flow (current US$) in 1961 in World?
Provide a succinct answer. -8.64e+07. What is the difference between the Aid flow (current US$) in 1960 and Aid flow (current US$) in 1962 in World?
Your answer should be compact. -7.72e+07. What is the difference between the Aid flow (current US$) of 1960 and Aid flow (current US$) of 1963 in World?
Your answer should be compact. -3.78e+07. What is the difference between the Aid flow (current US$) in 1961 and Aid flow (current US$) in 1962 in World?
Your response must be concise. 9.20e+06. What is the difference between the Aid flow (current US$) in 1961 and Aid flow (current US$) in 1963 in World?
Ensure brevity in your answer.  4.86e+07. What is the difference between the Aid flow (current US$) of 1962 and Aid flow (current US$) of 1963 in World?
Provide a succinct answer. 3.94e+07. What is the ratio of the Aid flow (current US$) of 1960 in Middle East & North Africa (developing only) to that in Middle income?
Ensure brevity in your answer.  0.96. What is the ratio of the Aid flow (current US$) of 1961 in Middle East & North Africa (developing only) to that in Middle income?
Provide a short and direct response. 1. What is the ratio of the Aid flow (current US$) of 1962 in Middle East & North Africa (developing only) to that in Middle income?
Ensure brevity in your answer.  0.99. What is the ratio of the Aid flow (current US$) in 1963 in Middle East & North Africa (developing only) to that in Middle income?
Ensure brevity in your answer.  0.93. What is the ratio of the Aid flow (current US$) in 1960 in Middle East & North Africa (developing only) to that in Sub-Saharan Africa (all income levels)?
Give a very brief answer. 1.25. What is the ratio of the Aid flow (current US$) of 1961 in Middle East & North Africa (developing only) to that in Sub-Saharan Africa (all income levels)?
Your answer should be very brief. 1.53. What is the ratio of the Aid flow (current US$) in 1962 in Middle East & North Africa (developing only) to that in Sub-Saharan Africa (all income levels)?
Provide a short and direct response. 1.24. What is the ratio of the Aid flow (current US$) in 1963 in Middle East & North Africa (developing only) to that in Sub-Saharan Africa (all income levels)?
Your answer should be very brief. 0.92. What is the ratio of the Aid flow (current US$) in 1960 in Middle East & North Africa (developing only) to that in Sub-Saharan Africa (developing only)?
Your answer should be very brief. 1.25. What is the ratio of the Aid flow (current US$) of 1961 in Middle East & North Africa (developing only) to that in Sub-Saharan Africa (developing only)?
Keep it short and to the point. 1.53. What is the ratio of the Aid flow (current US$) of 1962 in Middle East & North Africa (developing only) to that in Sub-Saharan Africa (developing only)?
Your answer should be compact. 1.24. What is the ratio of the Aid flow (current US$) of 1963 in Middle East & North Africa (developing only) to that in Sub-Saharan Africa (developing only)?
Ensure brevity in your answer.  0.92. What is the ratio of the Aid flow (current US$) in 1960 in Middle East & North Africa (developing only) to that in Upper middle income?
Provide a short and direct response. 1.07. What is the ratio of the Aid flow (current US$) of 1961 in Middle East & North Africa (developing only) to that in Upper middle income?
Your response must be concise. 1.06. What is the ratio of the Aid flow (current US$) of 1962 in Middle East & North Africa (developing only) to that in Upper middle income?
Your answer should be very brief. 1.11. What is the ratio of the Aid flow (current US$) of 1963 in Middle East & North Africa (developing only) to that in Upper middle income?
Provide a short and direct response. 1.22. What is the ratio of the Aid flow (current US$) in 1960 in Middle East & North Africa (developing only) to that in World?
Your answer should be compact. 0.49. What is the ratio of the Aid flow (current US$) in 1961 in Middle East & North Africa (developing only) to that in World?
Make the answer very short. 0.53. What is the ratio of the Aid flow (current US$) of 1962 in Middle East & North Africa (developing only) to that in World?
Offer a very short reply. 0.47. What is the ratio of the Aid flow (current US$) of 1963 in Middle East & North Africa (developing only) to that in World?
Provide a short and direct response. 0.38. What is the ratio of the Aid flow (current US$) of 1960 in Middle income to that in Sub-Saharan Africa (all income levels)?
Make the answer very short. 1.29. What is the ratio of the Aid flow (current US$) in 1961 in Middle income to that in Sub-Saharan Africa (all income levels)?
Your answer should be compact. 1.53. What is the ratio of the Aid flow (current US$) in 1962 in Middle income to that in Sub-Saharan Africa (all income levels)?
Your answer should be compact. 1.25. What is the ratio of the Aid flow (current US$) of 1963 in Middle income to that in Sub-Saharan Africa (all income levels)?
Your answer should be compact. 0.99. What is the ratio of the Aid flow (current US$) of 1960 in Middle income to that in Sub-Saharan Africa (developing only)?
Ensure brevity in your answer.  1.29. What is the ratio of the Aid flow (current US$) in 1961 in Middle income to that in Sub-Saharan Africa (developing only)?
Your answer should be very brief. 1.53. What is the ratio of the Aid flow (current US$) in 1962 in Middle income to that in Sub-Saharan Africa (developing only)?
Offer a very short reply. 1.25. What is the ratio of the Aid flow (current US$) of 1960 in Middle income to that in Upper middle income?
Your answer should be compact. 1.11. What is the ratio of the Aid flow (current US$) in 1961 in Middle income to that in Upper middle income?
Ensure brevity in your answer.  1.06. What is the ratio of the Aid flow (current US$) of 1962 in Middle income to that in Upper middle income?
Offer a terse response. 1.13. What is the ratio of the Aid flow (current US$) in 1963 in Middle income to that in Upper middle income?
Make the answer very short. 1.31. What is the ratio of the Aid flow (current US$) of 1960 in Middle income to that in World?
Make the answer very short. 0.51. What is the ratio of the Aid flow (current US$) in 1961 in Middle income to that in World?
Your answer should be compact. 0.53. What is the ratio of the Aid flow (current US$) in 1962 in Middle income to that in World?
Offer a very short reply. 0.47. What is the ratio of the Aid flow (current US$) in 1963 in Middle income to that in World?
Provide a succinct answer. 0.41. What is the ratio of the Aid flow (current US$) of 1960 in Sub-Saharan Africa (all income levels) to that in Sub-Saharan Africa (developing only)?
Make the answer very short. 1. What is the ratio of the Aid flow (current US$) of 1961 in Sub-Saharan Africa (all income levels) to that in Sub-Saharan Africa (developing only)?
Offer a terse response. 1. What is the ratio of the Aid flow (current US$) in 1960 in Sub-Saharan Africa (all income levels) to that in Upper middle income?
Provide a short and direct response. 0.86. What is the ratio of the Aid flow (current US$) of 1961 in Sub-Saharan Africa (all income levels) to that in Upper middle income?
Your response must be concise. 0.7. What is the ratio of the Aid flow (current US$) of 1962 in Sub-Saharan Africa (all income levels) to that in Upper middle income?
Your answer should be compact. 0.9. What is the ratio of the Aid flow (current US$) in 1963 in Sub-Saharan Africa (all income levels) to that in Upper middle income?
Offer a terse response. 1.32. What is the ratio of the Aid flow (current US$) of 1960 in Sub-Saharan Africa (all income levels) to that in World?
Provide a succinct answer. 0.39. What is the ratio of the Aid flow (current US$) in 1961 in Sub-Saharan Africa (all income levels) to that in World?
Offer a very short reply. 0.35. What is the ratio of the Aid flow (current US$) in 1962 in Sub-Saharan Africa (all income levels) to that in World?
Make the answer very short. 0.38. What is the ratio of the Aid flow (current US$) of 1963 in Sub-Saharan Africa (all income levels) to that in World?
Offer a terse response. 0.41. What is the ratio of the Aid flow (current US$) in 1960 in Sub-Saharan Africa (developing only) to that in Upper middle income?
Provide a succinct answer. 0.86. What is the ratio of the Aid flow (current US$) in 1961 in Sub-Saharan Africa (developing only) to that in Upper middle income?
Offer a very short reply. 0.7. What is the ratio of the Aid flow (current US$) of 1962 in Sub-Saharan Africa (developing only) to that in Upper middle income?
Keep it short and to the point. 0.9. What is the ratio of the Aid flow (current US$) of 1963 in Sub-Saharan Africa (developing only) to that in Upper middle income?
Your response must be concise. 1.32. What is the ratio of the Aid flow (current US$) of 1960 in Sub-Saharan Africa (developing only) to that in World?
Make the answer very short. 0.39. What is the ratio of the Aid flow (current US$) in 1961 in Sub-Saharan Africa (developing only) to that in World?
Your answer should be very brief. 0.35. What is the ratio of the Aid flow (current US$) in 1962 in Sub-Saharan Africa (developing only) to that in World?
Offer a very short reply. 0.38. What is the ratio of the Aid flow (current US$) in 1963 in Sub-Saharan Africa (developing only) to that in World?
Give a very brief answer. 0.41. What is the ratio of the Aid flow (current US$) of 1960 in Upper middle income to that in World?
Offer a terse response. 0.46. What is the ratio of the Aid flow (current US$) of 1961 in Upper middle income to that in World?
Provide a short and direct response. 0.5. What is the ratio of the Aid flow (current US$) of 1962 in Upper middle income to that in World?
Offer a terse response. 0.42. What is the ratio of the Aid flow (current US$) of 1963 in Upper middle income to that in World?
Offer a terse response. 0.31. What is the difference between the highest and the second highest Aid flow (current US$) in 1960?
Ensure brevity in your answer.  3.86e+08. What is the difference between the highest and the second highest Aid flow (current US$) of 1961?
Give a very brief answer. 4.06e+08. What is the difference between the highest and the second highest Aid flow (current US$) in 1962?
Offer a very short reply. 4.54e+08. What is the difference between the highest and the second highest Aid flow (current US$) of 1963?
Your response must be concise. 4.84e+08. What is the difference between the highest and the lowest Aid flow (current US$) of 1960?
Keep it short and to the point. 4.76e+08. What is the difference between the highest and the lowest Aid flow (current US$) of 1961?
Ensure brevity in your answer.  5.66e+08. What is the difference between the highest and the lowest Aid flow (current US$) of 1962?
Give a very brief answer. 5.35e+08. What is the difference between the highest and the lowest Aid flow (current US$) of 1963?
Your response must be concise. 5.66e+08. 